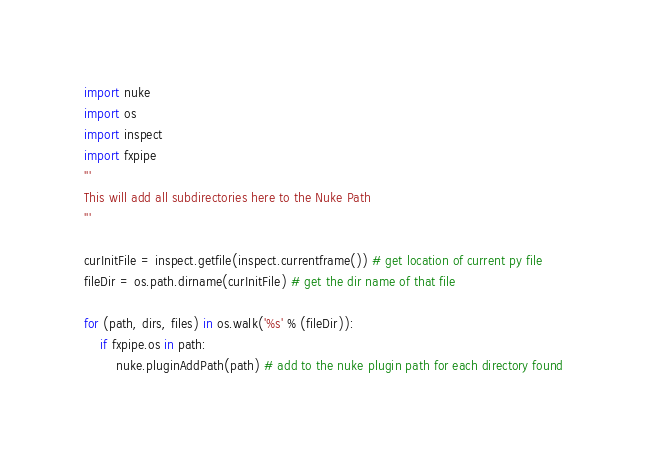Convert code to text. <code><loc_0><loc_0><loc_500><loc_500><_Python_>import nuke
import os
import inspect
import fxpipe
'''
This will add all subdirectories here to the Nuke Path
'''

curInitFile = inspect.getfile(inspect.currentframe()) # get location of current py file
fileDir = os.path.dirname(curInitFile) # get the dir name of that file

for (path, dirs, files) in os.walk('%s' % (fileDir)):
    if fxpipe.os in path:
        nuke.pluginAddPath(path) # add to the nuke plugin path for each directory found
</code> 